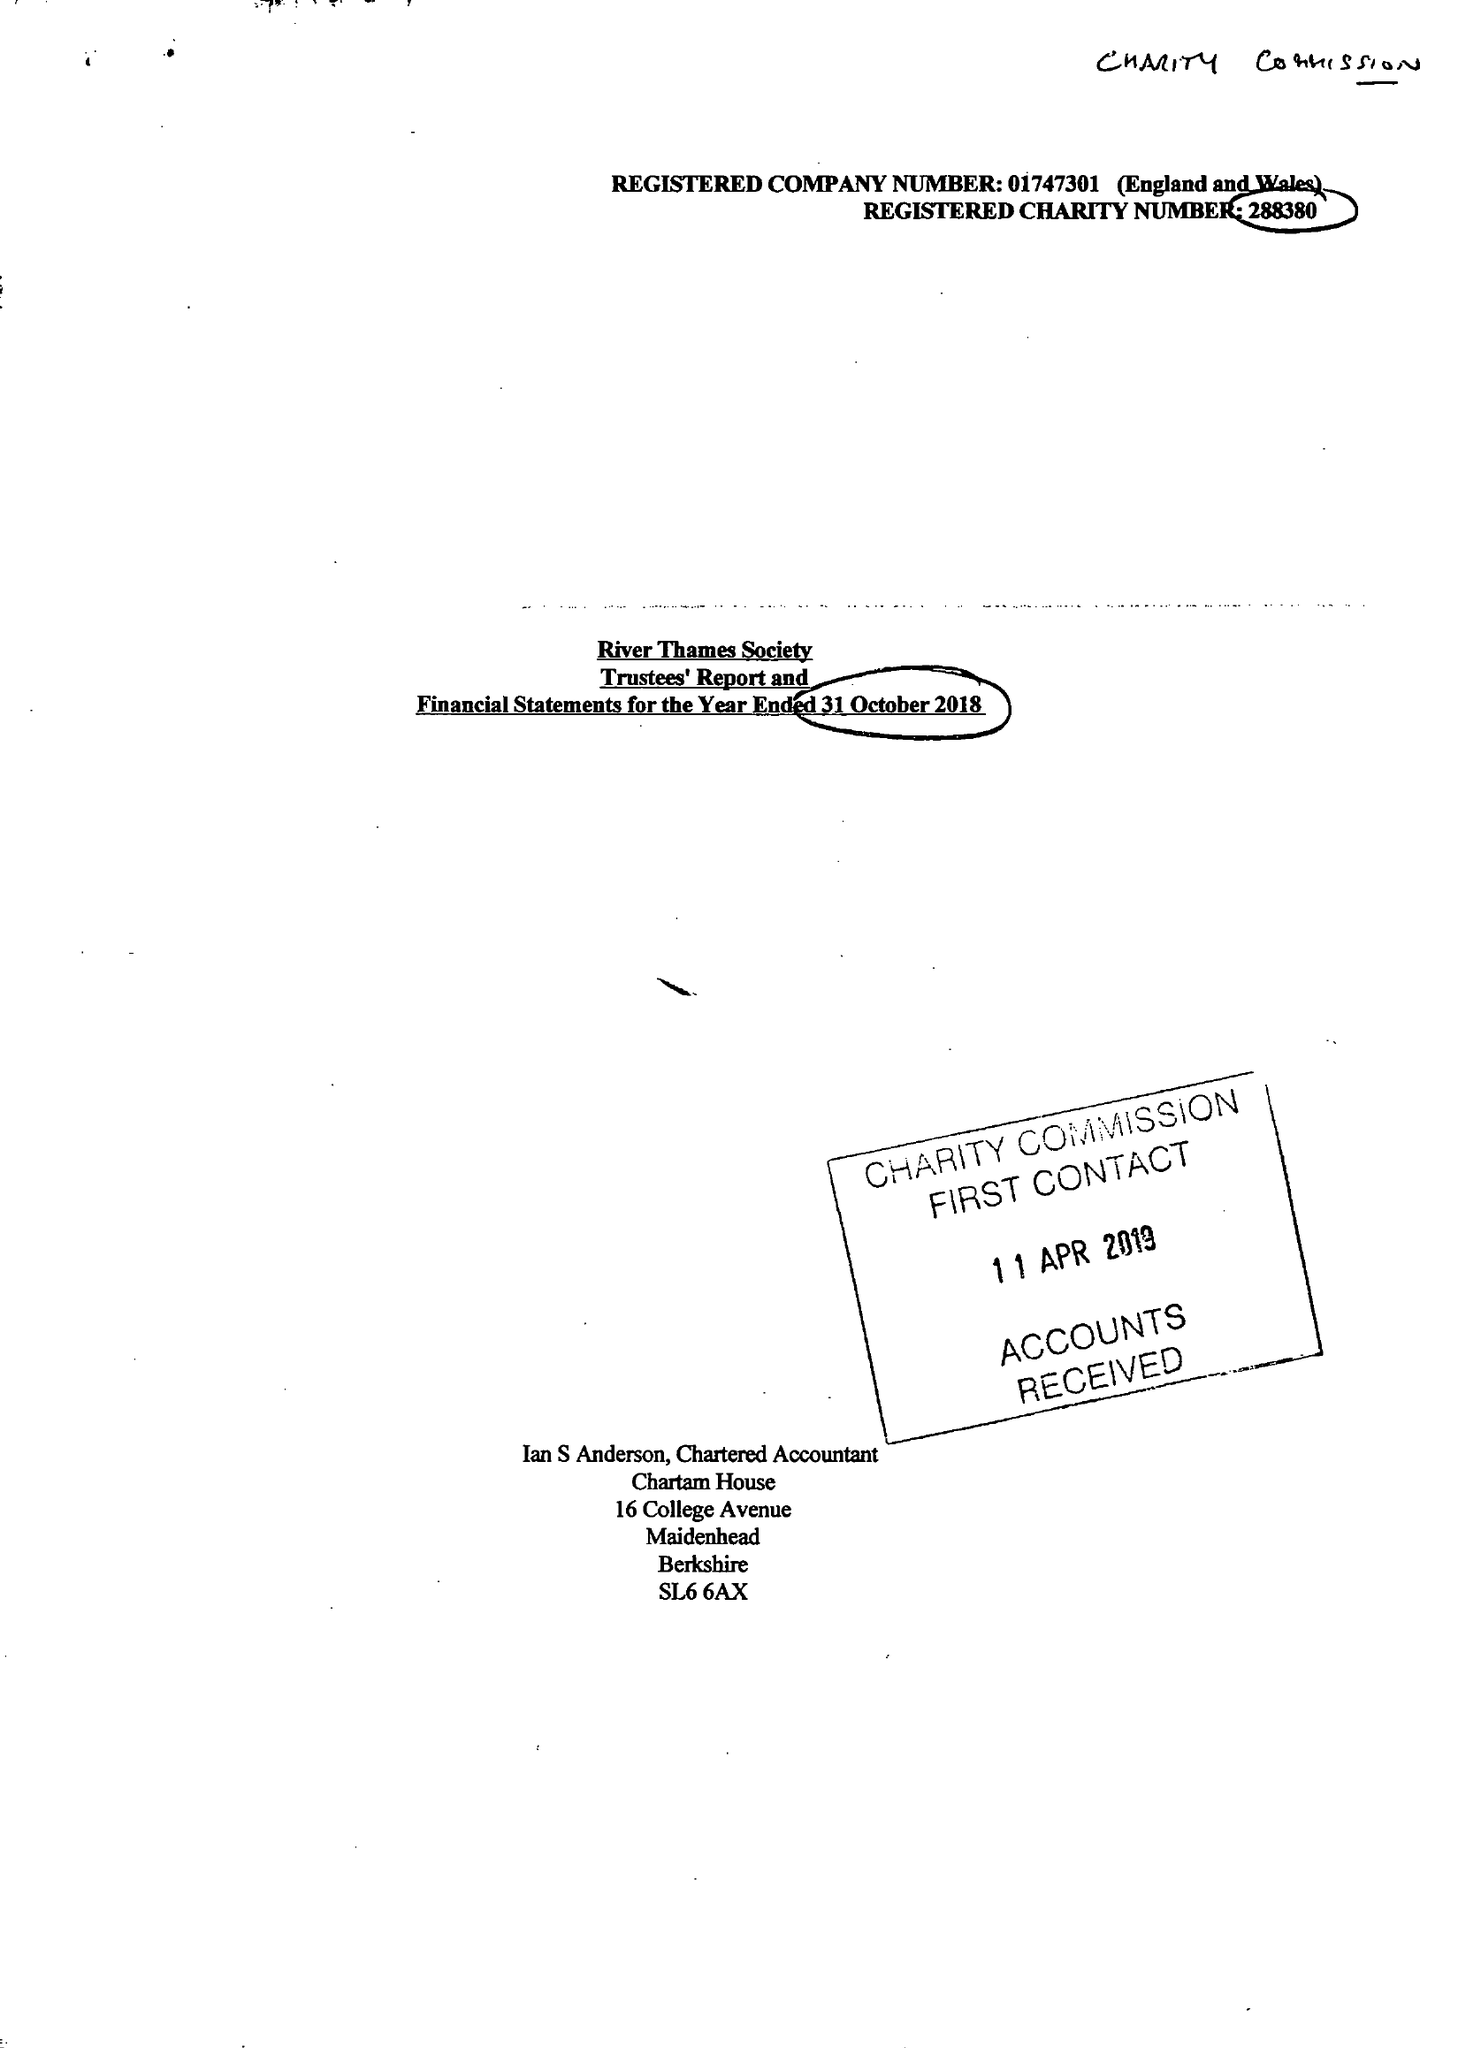What is the value for the address__postcode?
Answer the question using a single word or phrase. SL4 1JP 